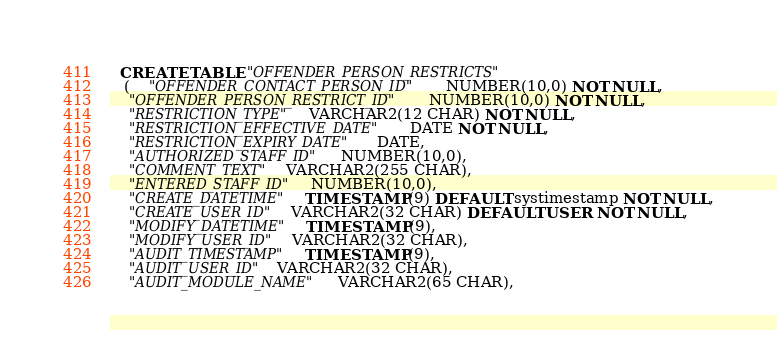<code> <loc_0><loc_0><loc_500><loc_500><_SQL_>
  CREATE TABLE "OFFENDER_PERSON_RESTRICTS"
   (    "OFFENDER_CONTACT_PERSON_ID" NUMBER(10,0) NOT NULL,
    "OFFENDER_PERSON_RESTRICT_ID" NUMBER(10,0) NOT NULL,
    "RESTRICTION_TYPE" VARCHAR2(12 CHAR) NOT NULL,
    "RESTRICTION_EFFECTIVE_DATE" DATE NOT NULL,
    "RESTRICTION_EXPIRY_DATE" DATE,
    "AUTHORIZED_STAFF_ID" NUMBER(10,0),
    "COMMENT_TEXT" VARCHAR2(255 CHAR),
    "ENTERED_STAFF_ID" NUMBER(10,0),
    "CREATE_DATETIME" TIMESTAMP (9) DEFAULT systimestamp NOT NULL,
    "CREATE_USER_ID" VARCHAR2(32 CHAR) DEFAULT USER NOT NULL,
    "MODIFY_DATETIME" TIMESTAMP (9),
    "MODIFY_USER_ID" VARCHAR2(32 CHAR),
    "AUDIT_TIMESTAMP" TIMESTAMP (9),
    "AUDIT_USER_ID" VARCHAR2(32 CHAR),
    "AUDIT_MODULE_NAME" VARCHAR2(65 CHAR),</code> 